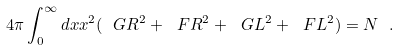Convert formula to latex. <formula><loc_0><loc_0><loc_500><loc_500>4 \pi \int ^ { \infty } _ { 0 } d x x ^ { 2 } ( \ G R ^ { 2 } + \ F R ^ { 2 } + \ G L ^ { 2 } + \ F L ^ { 2 } ) = N \ .</formula> 